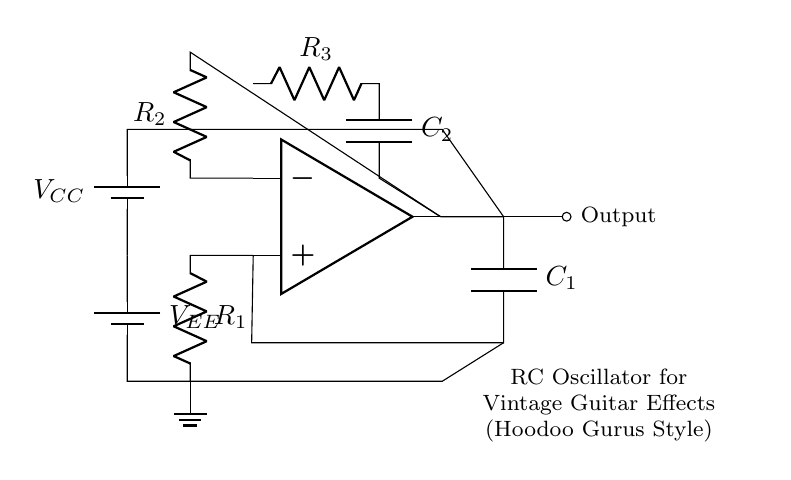What type of oscillator is shown in the diagram? The diagram represents an RC oscillator, which uses resistors and capacitors to generate oscillating signals.
Answer: RC oscillator What components are used in the feedback loop of the op-amp? The feedback loop contains resistor R2 and capacitor C1, which are responsible for generating oscillations by controlling the signal feedback into the op-amp.
Answer: R2, C1 What is the voltage of the power supply in the circuit? The circuit has two power supplies labeled VCC and VEE; however, the specific voltage values are not shown in the diagram. They are often typical values such as 9V or 12V in similar circuits.
Answer: Not specified How many resistors are present in the circuit? The circuit diagram contains three resistors, labeled R1, R2, and R3, which are integral for the operation of the oscillator.
Answer: 3 Explain how the output is generated in this RC oscillator. The output is generated by the op-amp, which amplifies the oscillating signal created by the interaction of the resistors and capacitors in the feedback loop, providing a continuous oscillating output.
Answer: Through the op-amp What effect would increasing the value of capacitor C1 have? Increasing the value of capacitor C1 would typically lower the frequency of the oscillation, as a larger capacitor takes longer to charge and discharge, thus affecting the time constant in the RC circuit.
Answer: Lowers oscillation frequency 